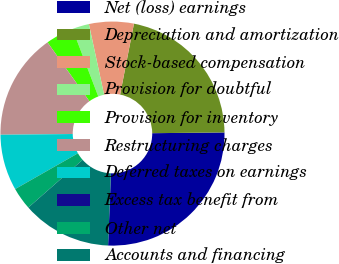Convert chart. <chart><loc_0><loc_0><loc_500><loc_500><pie_chart><fcel>Net (loss) earnings<fcel>Depreciation and amortization<fcel>Stock-based compensation<fcel>Provision for doubtful<fcel>Provision for inventory<fcel>Restructuring charges<fcel>Deferred taxes on earnings<fcel>Excess tax benefit from<fcel>Other net<fcel>Accounts and financing<nl><fcel>25.79%<fcel>21.77%<fcel>6.45%<fcel>2.43%<fcel>4.04%<fcel>15.32%<fcel>8.07%<fcel>0.01%<fcel>3.23%<fcel>12.9%<nl></chart> 